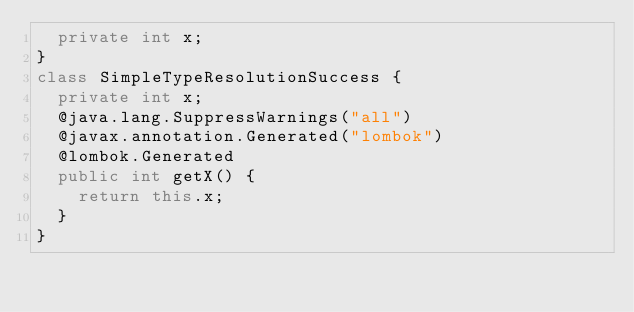Convert code to text. <code><loc_0><loc_0><loc_500><loc_500><_Java_>	private int x;
}
class SimpleTypeResolutionSuccess {
	private int x;
	@java.lang.SuppressWarnings("all")
	@javax.annotation.Generated("lombok")
	@lombok.Generated
	public int getX() {
		return this.x;
	}
}
</code> 